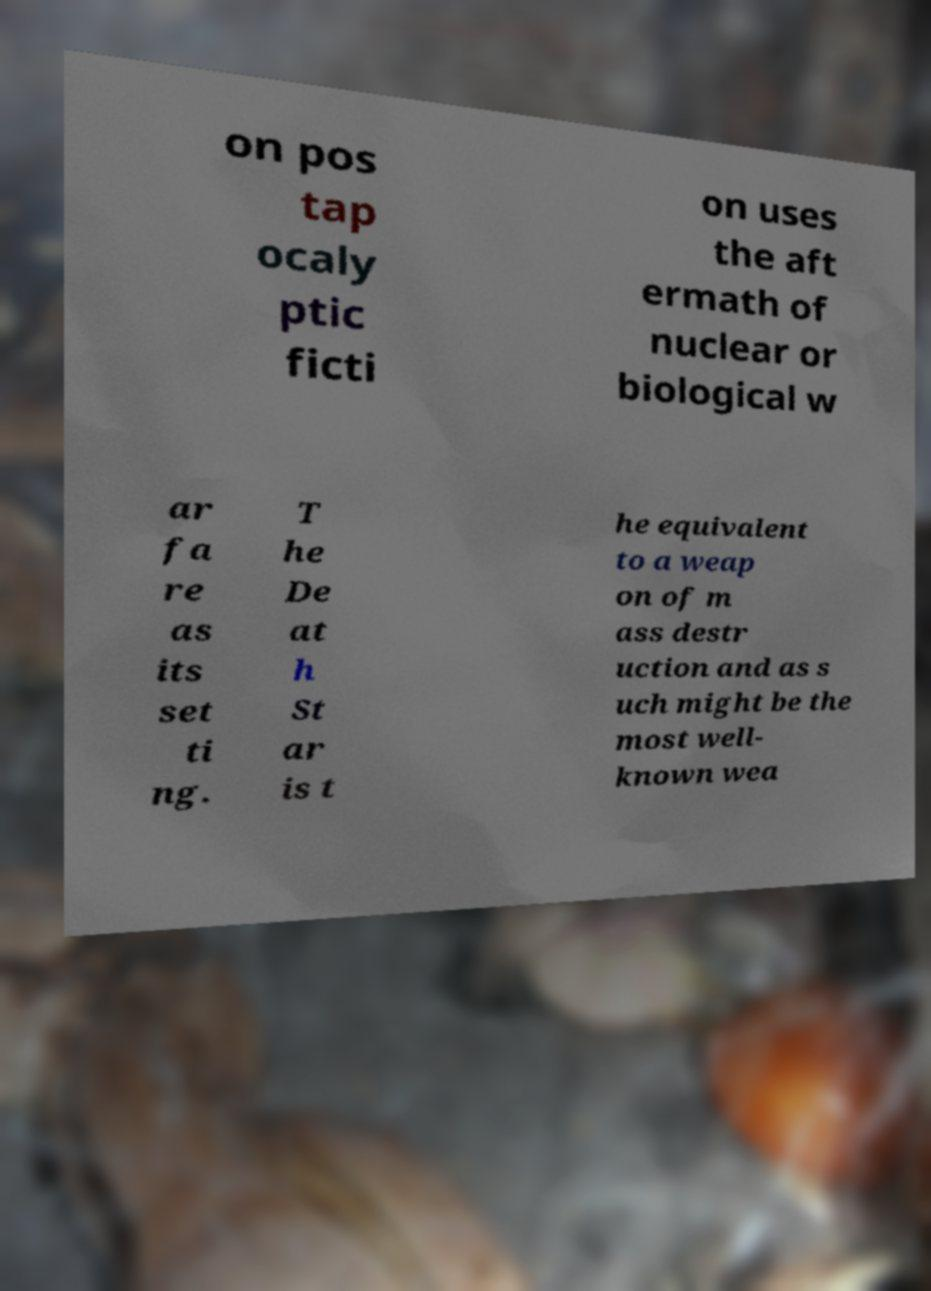For documentation purposes, I need the text within this image transcribed. Could you provide that? on pos tap ocaly ptic ficti on uses the aft ermath of nuclear or biological w ar fa re as its set ti ng. T he De at h St ar is t he equivalent to a weap on of m ass destr uction and as s uch might be the most well- known wea 